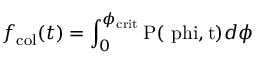<formula> <loc_0><loc_0><loc_500><loc_500>f _ { c o l } ( t ) = \int _ { 0 } ^ { \phi _ { c r i t } } P ( \ p h i , t ) d \phi</formula> 